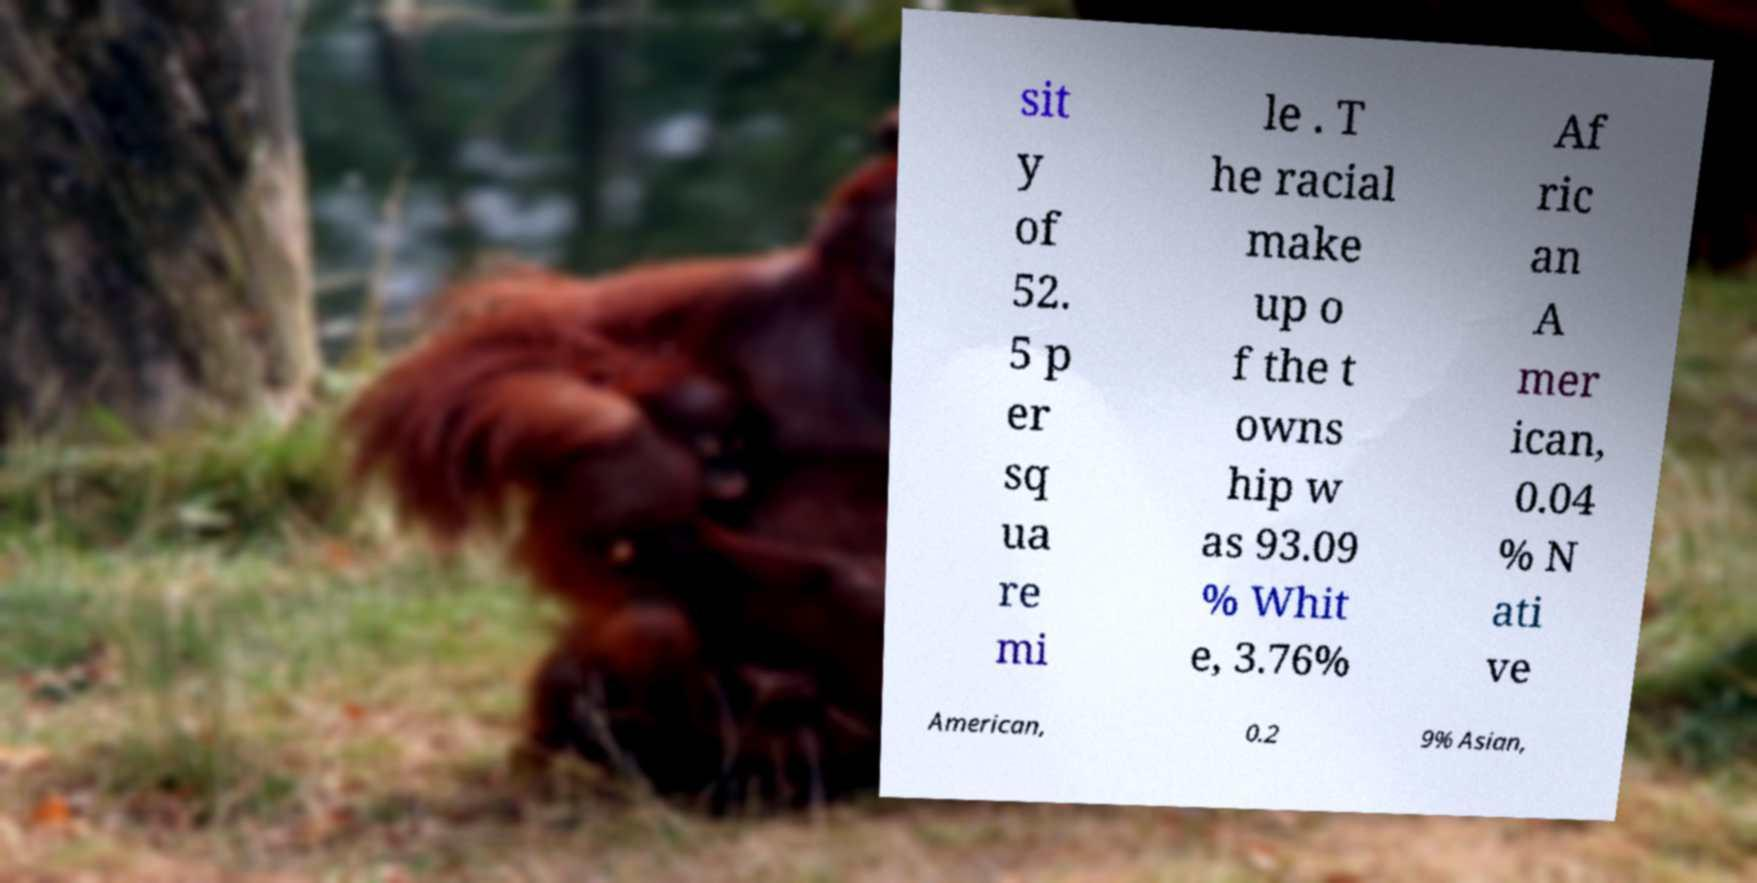Please identify and transcribe the text found in this image. sit y of 52. 5 p er sq ua re mi le . T he racial make up o f the t owns hip w as 93.09 % Whit e, 3.76% Af ric an A mer ican, 0.04 % N ati ve American, 0.2 9% Asian, 